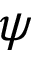<formula> <loc_0><loc_0><loc_500><loc_500>\psi</formula> 